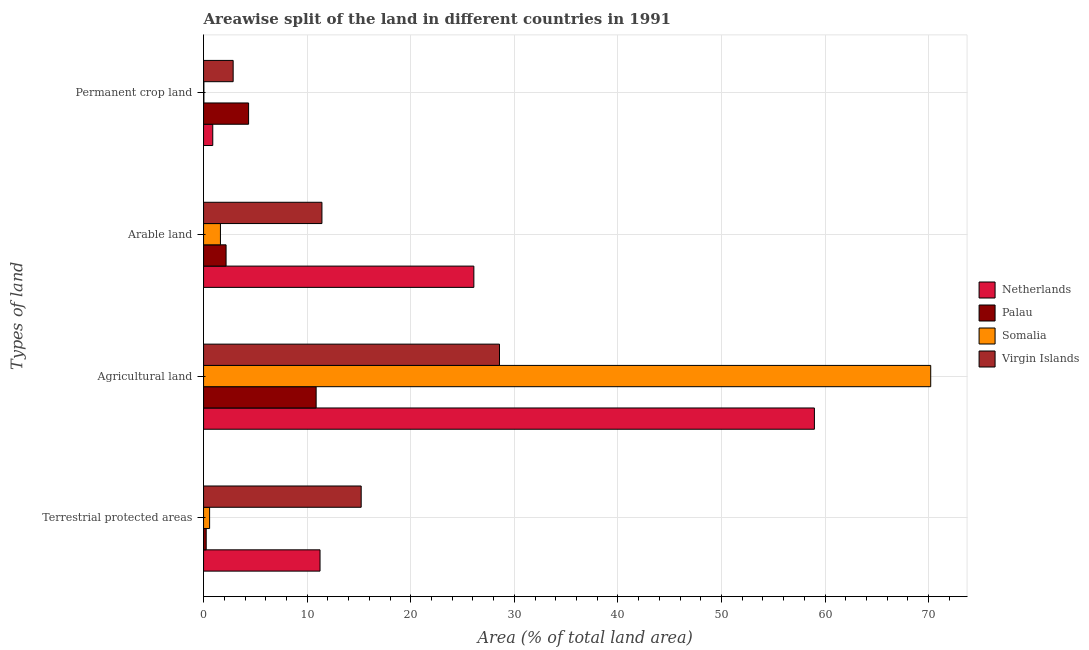How many different coloured bars are there?
Your answer should be compact. 4. How many groups of bars are there?
Your answer should be very brief. 4. Are the number of bars per tick equal to the number of legend labels?
Ensure brevity in your answer.  Yes. How many bars are there on the 3rd tick from the bottom?
Your answer should be compact. 4. What is the label of the 3rd group of bars from the top?
Your answer should be very brief. Agricultural land. What is the percentage of area under permanent crop land in Somalia?
Your answer should be very brief. 0.03. Across all countries, what is the maximum percentage of area under agricultural land?
Offer a very short reply. 70.2. Across all countries, what is the minimum percentage of land under terrestrial protection?
Provide a succinct answer. 0.25. In which country was the percentage of area under permanent crop land maximum?
Keep it short and to the point. Palau. In which country was the percentage of area under permanent crop land minimum?
Provide a succinct answer. Somalia. What is the total percentage of area under agricultural land in the graph?
Provide a succinct answer. 168.62. What is the difference between the percentage of area under permanent crop land in Virgin Islands and that in Somalia?
Your answer should be compact. 2.83. What is the difference between the percentage of land under terrestrial protection in Somalia and the percentage of area under permanent crop land in Netherlands?
Provide a succinct answer. -0.3. What is the average percentage of area under arable land per country?
Provide a succinct answer. 10.33. What is the difference between the percentage of land under terrestrial protection and percentage of area under permanent crop land in Netherlands?
Keep it short and to the point. 10.36. In how many countries, is the percentage of area under permanent crop land greater than 22 %?
Offer a very short reply. 0. What is the ratio of the percentage of land under terrestrial protection in Virgin Islands to that in Palau?
Offer a very short reply. 59.84. Is the percentage of area under arable land in Virgin Islands less than that in Palau?
Give a very brief answer. No. Is the difference between the percentage of land under terrestrial protection in Virgin Islands and Netherlands greater than the difference between the percentage of area under permanent crop land in Virgin Islands and Netherlands?
Your answer should be very brief. Yes. What is the difference between the highest and the second highest percentage of area under agricultural land?
Your answer should be compact. 11.23. What is the difference between the highest and the lowest percentage of land under terrestrial protection?
Give a very brief answer. 14.96. In how many countries, is the percentage of area under arable land greater than the average percentage of area under arable land taken over all countries?
Your answer should be very brief. 2. Is the sum of the percentage of area under permanent crop land in Palau and Somalia greater than the maximum percentage of area under arable land across all countries?
Provide a short and direct response. No. What does the 2nd bar from the top in Agricultural land represents?
Your response must be concise. Somalia. What does the 3rd bar from the bottom in Terrestrial protected areas represents?
Your answer should be compact. Somalia. Is it the case that in every country, the sum of the percentage of land under terrestrial protection and percentage of area under agricultural land is greater than the percentage of area under arable land?
Provide a short and direct response. Yes. How many bars are there?
Provide a short and direct response. 16. What is the difference between two consecutive major ticks on the X-axis?
Ensure brevity in your answer.  10. Does the graph contain grids?
Offer a terse response. Yes. Where does the legend appear in the graph?
Provide a short and direct response. Center right. How many legend labels are there?
Your answer should be very brief. 4. What is the title of the graph?
Keep it short and to the point. Areawise split of the land in different countries in 1991. What is the label or title of the X-axis?
Offer a terse response. Area (% of total land area). What is the label or title of the Y-axis?
Make the answer very short. Types of land. What is the Area (% of total land area) in Netherlands in Terrestrial protected areas?
Make the answer very short. 11.25. What is the Area (% of total land area) of Palau in Terrestrial protected areas?
Provide a short and direct response. 0.25. What is the Area (% of total land area) of Somalia in Terrestrial protected areas?
Offer a terse response. 0.58. What is the Area (% of total land area) in Virgin Islands in Terrestrial protected areas?
Your response must be concise. 15.22. What is the Area (% of total land area) of Netherlands in Agricultural land?
Offer a terse response. 58.98. What is the Area (% of total land area) of Palau in Agricultural land?
Your response must be concise. 10.87. What is the Area (% of total land area) of Somalia in Agricultural land?
Your answer should be very brief. 70.2. What is the Area (% of total land area) of Virgin Islands in Agricultural land?
Keep it short and to the point. 28.57. What is the Area (% of total land area) of Netherlands in Arable land?
Keep it short and to the point. 26.1. What is the Area (% of total land area) of Palau in Arable land?
Your response must be concise. 2.17. What is the Area (% of total land area) in Somalia in Arable land?
Your response must be concise. 1.63. What is the Area (% of total land area) of Virgin Islands in Arable land?
Provide a succinct answer. 11.43. What is the Area (% of total land area) of Netherlands in Permanent crop land?
Offer a terse response. 0.89. What is the Area (% of total land area) in Palau in Permanent crop land?
Provide a succinct answer. 4.35. What is the Area (% of total land area) in Somalia in Permanent crop land?
Keep it short and to the point. 0.03. What is the Area (% of total land area) in Virgin Islands in Permanent crop land?
Offer a terse response. 2.86. Across all Types of land, what is the maximum Area (% of total land area) of Netherlands?
Your answer should be very brief. 58.98. Across all Types of land, what is the maximum Area (% of total land area) in Palau?
Give a very brief answer. 10.87. Across all Types of land, what is the maximum Area (% of total land area) of Somalia?
Offer a terse response. 70.2. Across all Types of land, what is the maximum Area (% of total land area) of Virgin Islands?
Your answer should be very brief. 28.57. Across all Types of land, what is the minimum Area (% of total land area) in Netherlands?
Make the answer very short. 0.89. Across all Types of land, what is the minimum Area (% of total land area) of Palau?
Ensure brevity in your answer.  0.25. Across all Types of land, what is the minimum Area (% of total land area) in Somalia?
Provide a succinct answer. 0.03. Across all Types of land, what is the minimum Area (% of total land area) of Virgin Islands?
Offer a terse response. 2.86. What is the total Area (% of total land area) in Netherlands in the graph?
Provide a succinct answer. 97.2. What is the total Area (% of total land area) in Palau in the graph?
Your answer should be compact. 17.65. What is the total Area (% of total land area) in Somalia in the graph?
Your answer should be very brief. 72.45. What is the total Area (% of total land area) of Virgin Islands in the graph?
Ensure brevity in your answer.  58.08. What is the difference between the Area (% of total land area) of Netherlands in Terrestrial protected areas and that in Agricultural land?
Your response must be concise. -47.73. What is the difference between the Area (% of total land area) in Palau in Terrestrial protected areas and that in Agricultural land?
Your answer should be compact. -10.62. What is the difference between the Area (% of total land area) in Somalia in Terrestrial protected areas and that in Agricultural land?
Provide a short and direct response. -69.62. What is the difference between the Area (% of total land area) of Virgin Islands in Terrestrial protected areas and that in Agricultural land?
Make the answer very short. -13.35. What is the difference between the Area (% of total land area) in Netherlands in Terrestrial protected areas and that in Arable land?
Offer a terse response. -14.85. What is the difference between the Area (% of total land area) in Palau in Terrestrial protected areas and that in Arable land?
Your answer should be very brief. -1.92. What is the difference between the Area (% of total land area) of Somalia in Terrestrial protected areas and that in Arable land?
Your response must be concise. -1.05. What is the difference between the Area (% of total land area) in Virgin Islands in Terrestrial protected areas and that in Arable land?
Give a very brief answer. 3.79. What is the difference between the Area (% of total land area) in Netherlands in Terrestrial protected areas and that in Permanent crop land?
Provide a short and direct response. 10.36. What is the difference between the Area (% of total land area) of Palau in Terrestrial protected areas and that in Permanent crop land?
Your answer should be compact. -4.09. What is the difference between the Area (% of total land area) in Somalia in Terrestrial protected areas and that in Permanent crop land?
Make the answer very short. 0.55. What is the difference between the Area (% of total land area) in Virgin Islands in Terrestrial protected areas and that in Permanent crop land?
Your response must be concise. 12.36. What is the difference between the Area (% of total land area) of Netherlands in Agricultural land and that in Arable land?
Your response must be concise. 32.88. What is the difference between the Area (% of total land area) in Palau in Agricultural land and that in Arable land?
Provide a short and direct response. 8.7. What is the difference between the Area (% of total land area) of Somalia in Agricultural land and that in Arable land?
Ensure brevity in your answer.  68.58. What is the difference between the Area (% of total land area) in Virgin Islands in Agricultural land and that in Arable land?
Ensure brevity in your answer.  17.14. What is the difference between the Area (% of total land area) of Netherlands in Agricultural land and that in Permanent crop land?
Ensure brevity in your answer.  58.09. What is the difference between the Area (% of total land area) of Palau in Agricultural land and that in Permanent crop land?
Provide a succinct answer. 6.52. What is the difference between the Area (% of total land area) of Somalia in Agricultural land and that in Permanent crop land?
Your response must be concise. 70.17. What is the difference between the Area (% of total land area) in Virgin Islands in Agricultural land and that in Permanent crop land?
Your answer should be very brief. 25.71. What is the difference between the Area (% of total land area) in Netherlands in Arable land and that in Permanent crop land?
Offer a terse response. 25.21. What is the difference between the Area (% of total land area) in Palau in Arable land and that in Permanent crop land?
Offer a very short reply. -2.17. What is the difference between the Area (% of total land area) of Somalia in Arable land and that in Permanent crop land?
Keep it short and to the point. 1.6. What is the difference between the Area (% of total land area) in Virgin Islands in Arable land and that in Permanent crop land?
Give a very brief answer. 8.57. What is the difference between the Area (% of total land area) of Netherlands in Terrestrial protected areas and the Area (% of total land area) of Palau in Agricultural land?
Ensure brevity in your answer.  0.38. What is the difference between the Area (% of total land area) of Netherlands in Terrestrial protected areas and the Area (% of total land area) of Somalia in Agricultural land?
Make the answer very short. -58.96. What is the difference between the Area (% of total land area) in Netherlands in Terrestrial protected areas and the Area (% of total land area) in Virgin Islands in Agricultural land?
Provide a succinct answer. -17.33. What is the difference between the Area (% of total land area) in Palau in Terrestrial protected areas and the Area (% of total land area) in Somalia in Agricultural land?
Provide a succinct answer. -69.95. What is the difference between the Area (% of total land area) of Palau in Terrestrial protected areas and the Area (% of total land area) of Virgin Islands in Agricultural land?
Make the answer very short. -28.32. What is the difference between the Area (% of total land area) in Somalia in Terrestrial protected areas and the Area (% of total land area) in Virgin Islands in Agricultural land?
Keep it short and to the point. -27.99. What is the difference between the Area (% of total land area) of Netherlands in Terrestrial protected areas and the Area (% of total land area) of Palau in Arable land?
Give a very brief answer. 9.07. What is the difference between the Area (% of total land area) of Netherlands in Terrestrial protected areas and the Area (% of total land area) of Somalia in Arable land?
Provide a short and direct response. 9.62. What is the difference between the Area (% of total land area) of Netherlands in Terrestrial protected areas and the Area (% of total land area) of Virgin Islands in Arable land?
Your answer should be very brief. -0.18. What is the difference between the Area (% of total land area) in Palau in Terrestrial protected areas and the Area (% of total land area) in Somalia in Arable land?
Provide a succinct answer. -1.37. What is the difference between the Area (% of total land area) of Palau in Terrestrial protected areas and the Area (% of total land area) of Virgin Islands in Arable land?
Make the answer very short. -11.17. What is the difference between the Area (% of total land area) of Somalia in Terrestrial protected areas and the Area (% of total land area) of Virgin Islands in Arable land?
Your answer should be very brief. -10.84. What is the difference between the Area (% of total land area) of Netherlands in Terrestrial protected areas and the Area (% of total land area) of Palau in Permanent crop land?
Ensure brevity in your answer.  6.9. What is the difference between the Area (% of total land area) in Netherlands in Terrestrial protected areas and the Area (% of total land area) in Somalia in Permanent crop land?
Give a very brief answer. 11.21. What is the difference between the Area (% of total land area) in Netherlands in Terrestrial protected areas and the Area (% of total land area) in Virgin Islands in Permanent crop land?
Offer a terse response. 8.39. What is the difference between the Area (% of total land area) of Palau in Terrestrial protected areas and the Area (% of total land area) of Somalia in Permanent crop land?
Make the answer very short. 0.22. What is the difference between the Area (% of total land area) in Palau in Terrestrial protected areas and the Area (% of total land area) in Virgin Islands in Permanent crop land?
Keep it short and to the point. -2.6. What is the difference between the Area (% of total land area) of Somalia in Terrestrial protected areas and the Area (% of total land area) of Virgin Islands in Permanent crop land?
Give a very brief answer. -2.27. What is the difference between the Area (% of total land area) in Netherlands in Agricultural land and the Area (% of total land area) in Palau in Arable land?
Your answer should be very brief. 56.8. What is the difference between the Area (% of total land area) in Netherlands in Agricultural land and the Area (% of total land area) in Somalia in Arable land?
Offer a very short reply. 57.35. What is the difference between the Area (% of total land area) of Netherlands in Agricultural land and the Area (% of total land area) of Virgin Islands in Arable land?
Ensure brevity in your answer.  47.55. What is the difference between the Area (% of total land area) in Palau in Agricultural land and the Area (% of total land area) in Somalia in Arable land?
Keep it short and to the point. 9.24. What is the difference between the Area (% of total land area) in Palau in Agricultural land and the Area (% of total land area) in Virgin Islands in Arable land?
Your response must be concise. -0.56. What is the difference between the Area (% of total land area) of Somalia in Agricultural land and the Area (% of total land area) of Virgin Islands in Arable land?
Offer a terse response. 58.78. What is the difference between the Area (% of total land area) of Netherlands in Agricultural land and the Area (% of total land area) of Palau in Permanent crop land?
Provide a succinct answer. 54.63. What is the difference between the Area (% of total land area) in Netherlands in Agricultural land and the Area (% of total land area) in Somalia in Permanent crop land?
Offer a terse response. 58.94. What is the difference between the Area (% of total land area) in Netherlands in Agricultural land and the Area (% of total land area) in Virgin Islands in Permanent crop land?
Provide a short and direct response. 56.12. What is the difference between the Area (% of total land area) of Palau in Agricultural land and the Area (% of total land area) of Somalia in Permanent crop land?
Offer a terse response. 10.84. What is the difference between the Area (% of total land area) of Palau in Agricultural land and the Area (% of total land area) of Virgin Islands in Permanent crop land?
Offer a terse response. 8.01. What is the difference between the Area (% of total land area) in Somalia in Agricultural land and the Area (% of total land area) in Virgin Islands in Permanent crop land?
Provide a succinct answer. 67.35. What is the difference between the Area (% of total land area) of Netherlands in Arable land and the Area (% of total land area) of Palau in Permanent crop land?
Make the answer very short. 21.75. What is the difference between the Area (% of total land area) of Netherlands in Arable land and the Area (% of total land area) of Somalia in Permanent crop land?
Give a very brief answer. 26.06. What is the difference between the Area (% of total land area) in Netherlands in Arable land and the Area (% of total land area) in Virgin Islands in Permanent crop land?
Keep it short and to the point. 23.24. What is the difference between the Area (% of total land area) of Palau in Arable land and the Area (% of total land area) of Somalia in Permanent crop land?
Offer a terse response. 2.14. What is the difference between the Area (% of total land area) of Palau in Arable land and the Area (% of total land area) of Virgin Islands in Permanent crop land?
Make the answer very short. -0.68. What is the difference between the Area (% of total land area) in Somalia in Arable land and the Area (% of total land area) in Virgin Islands in Permanent crop land?
Give a very brief answer. -1.23. What is the average Area (% of total land area) of Netherlands per Types of land?
Offer a terse response. 24.3. What is the average Area (% of total land area) of Palau per Types of land?
Your answer should be compact. 4.41. What is the average Area (% of total land area) of Somalia per Types of land?
Ensure brevity in your answer.  18.11. What is the average Area (% of total land area) in Virgin Islands per Types of land?
Ensure brevity in your answer.  14.52. What is the difference between the Area (% of total land area) in Netherlands and Area (% of total land area) in Palau in Terrestrial protected areas?
Provide a succinct answer. 10.99. What is the difference between the Area (% of total land area) in Netherlands and Area (% of total land area) in Somalia in Terrestrial protected areas?
Provide a short and direct response. 10.66. What is the difference between the Area (% of total land area) in Netherlands and Area (% of total land area) in Virgin Islands in Terrestrial protected areas?
Your response must be concise. -3.97. What is the difference between the Area (% of total land area) of Palau and Area (% of total land area) of Somalia in Terrestrial protected areas?
Make the answer very short. -0.33. What is the difference between the Area (% of total land area) in Palau and Area (% of total land area) in Virgin Islands in Terrestrial protected areas?
Make the answer very short. -14.96. What is the difference between the Area (% of total land area) of Somalia and Area (% of total land area) of Virgin Islands in Terrestrial protected areas?
Offer a terse response. -14.63. What is the difference between the Area (% of total land area) of Netherlands and Area (% of total land area) of Palau in Agricultural land?
Your response must be concise. 48.11. What is the difference between the Area (% of total land area) in Netherlands and Area (% of total land area) in Somalia in Agricultural land?
Provide a short and direct response. -11.23. What is the difference between the Area (% of total land area) in Netherlands and Area (% of total land area) in Virgin Islands in Agricultural land?
Your response must be concise. 30.4. What is the difference between the Area (% of total land area) in Palau and Area (% of total land area) in Somalia in Agricultural land?
Provide a short and direct response. -59.33. What is the difference between the Area (% of total land area) of Palau and Area (% of total land area) of Virgin Islands in Agricultural land?
Offer a terse response. -17.7. What is the difference between the Area (% of total land area) in Somalia and Area (% of total land area) in Virgin Islands in Agricultural land?
Offer a terse response. 41.63. What is the difference between the Area (% of total land area) in Netherlands and Area (% of total land area) in Palau in Arable land?
Give a very brief answer. 23.92. What is the difference between the Area (% of total land area) in Netherlands and Area (% of total land area) in Somalia in Arable land?
Give a very brief answer. 24.47. What is the difference between the Area (% of total land area) in Netherlands and Area (% of total land area) in Virgin Islands in Arable land?
Provide a succinct answer. 14.67. What is the difference between the Area (% of total land area) of Palau and Area (% of total land area) of Somalia in Arable land?
Your answer should be compact. 0.54. What is the difference between the Area (% of total land area) in Palau and Area (% of total land area) in Virgin Islands in Arable land?
Your response must be concise. -9.25. What is the difference between the Area (% of total land area) of Somalia and Area (% of total land area) of Virgin Islands in Arable land?
Provide a succinct answer. -9.8. What is the difference between the Area (% of total land area) of Netherlands and Area (% of total land area) of Palau in Permanent crop land?
Your answer should be compact. -3.46. What is the difference between the Area (% of total land area) of Netherlands and Area (% of total land area) of Somalia in Permanent crop land?
Provide a succinct answer. 0.86. What is the difference between the Area (% of total land area) in Netherlands and Area (% of total land area) in Virgin Islands in Permanent crop land?
Make the answer very short. -1.97. What is the difference between the Area (% of total land area) in Palau and Area (% of total land area) in Somalia in Permanent crop land?
Keep it short and to the point. 4.32. What is the difference between the Area (% of total land area) in Palau and Area (% of total land area) in Virgin Islands in Permanent crop land?
Make the answer very short. 1.49. What is the difference between the Area (% of total land area) in Somalia and Area (% of total land area) in Virgin Islands in Permanent crop land?
Offer a terse response. -2.83. What is the ratio of the Area (% of total land area) in Netherlands in Terrestrial protected areas to that in Agricultural land?
Your answer should be compact. 0.19. What is the ratio of the Area (% of total land area) in Palau in Terrestrial protected areas to that in Agricultural land?
Keep it short and to the point. 0.02. What is the ratio of the Area (% of total land area) in Somalia in Terrestrial protected areas to that in Agricultural land?
Your answer should be compact. 0.01. What is the ratio of the Area (% of total land area) in Virgin Islands in Terrestrial protected areas to that in Agricultural land?
Keep it short and to the point. 0.53. What is the ratio of the Area (% of total land area) of Netherlands in Terrestrial protected areas to that in Arable land?
Your answer should be compact. 0.43. What is the ratio of the Area (% of total land area) of Palau in Terrestrial protected areas to that in Arable land?
Your answer should be compact. 0.12. What is the ratio of the Area (% of total land area) in Somalia in Terrestrial protected areas to that in Arable land?
Ensure brevity in your answer.  0.36. What is the ratio of the Area (% of total land area) of Virgin Islands in Terrestrial protected areas to that in Arable land?
Offer a terse response. 1.33. What is the ratio of the Area (% of total land area) in Netherlands in Terrestrial protected areas to that in Permanent crop land?
Provide a succinct answer. 12.65. What is the ratio of the Area (% of total land area) of Palau in Terrestrial protected areas to that in Permanent crop land?
Your answer should be compact. 0.06. What is the ratio of the Area (% of total land area) of Somalia in Terrestrial protected areas to that in Permanent crop land?
Offer a terse response. 18.32. What is the ratio of the Area (% of total land area) in Virgin Islands in Terrestrial protected areas to that in Permanent crop land?
Your answer should be compact. 5.33. What is the ratio of the Area (% of total land area) of Netherlands in Agricultural land to that in Arable land?
Give a very brief answer. 2.26. What is the ratio of the Area (% of total land area) of Somalia in Agricultural land to that in Arable land?
Keep it short and to the point. 43.09. What is the ratio of the Area (% of total land area) in Virgin Islands in Agricultural land to that in Arable land?
Keep it short and to the point. 2.5. What is the ratio of the Area (% of total land area) in Netherlands in Agricultural land to that in Permanent crop land?
Offer a very short reply. 66.37. What is the ratio of the Area (% of total land area) of Somalia in Agricultural land to that in Permanent crop land?
Your answer should be compact. 2202.1. What is the ratio of the Area (% of total land area) in Virgin Islands in Agricultural land to that in Permanent crop land?
Offer a terse response. 10. What is the ratio of the Area (% of total land area) of Netherlands in Arable land to that in Permanent crop land?
Give a very brief answer. 29.37. What is the ratio of the Area (% of total land area) in Somalia in Arable land to that in Permanent crop land?
Provide a short and direct response. 51.1. What is the ratio of the Area (% of total land area) in Virgin Islands in Arable land to that in Permanent crop land?
Make the answer very short. 4. What is the difference between the highest and the second highest Area (% of total land area) in Netherlands?
Offer a very short reply. 32.88. What is the difference between the highest and the second highest Area (% of total land area) in Palau?
Make the answer very short. 6.52. What is the difference between the highest and the second highest Area (% of total land area) of Somalia?
Offer a very short reply. 68.58. What is the difference between the highest and the second highest Area (% of total land area) of Virgin Islands?
Your answer should be very brief. 13.35. What is the difference between the highest and the lowest Area (% of total land area) of Netherlands?
Offer a terse response. 58.09. What is the difference between the highest and the lowest Area (% of total land area) in Palau?
Your response must be concise. 10.62. What is the difference between the highest and the lowest Area (% of total land area) of Somalia?
Make the answer very short. 70.17. What is the difference between the highest and the lowest Area (% of total land area) in Virgin Islands?
Provide a short and direct response. 25.71. 